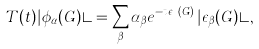Convert formula to latex. <formula><loc_0><loc_0><loc_500><loc_500>T ( t ) | \phi _ { \alpha } ( G ) \rangle = \sum _ { \beta } \alpha _ { \beta } e ^ { - t \epsilon _ { \beta } ( G ) } \, | \epsilon _ { \beta } ( G ) \rangle ,</formula> 